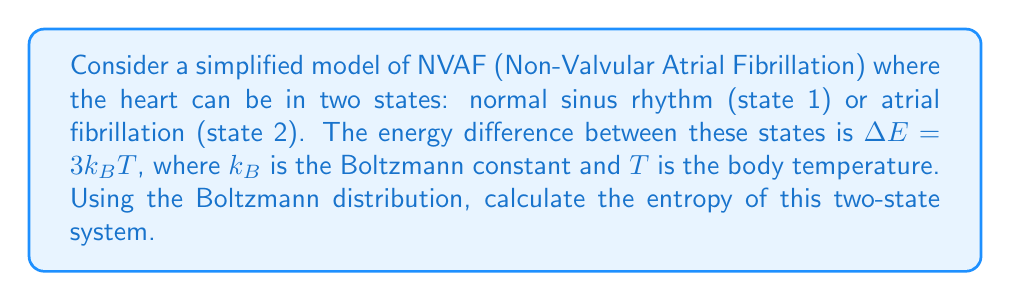Help me with this question. To solve this problem, we'll follow these steps:

1) The Boltzmann distribution gives the probability of a system being in a state with energy $E_i$:

   $$p_i = \frac{1}{Z} e^{-E_i/k_BT}$$

   where $Z$ is the partition function.

2) For a two-state system, the partition function is:

   $$Z = e^{-E_1/k_BT} + e^{-E_2/k_BT}$$

3) Let's set $E_1 = 0$ (reference state) and $E_2 = \Delta E = 3k_BT$. Then:

   $$Z = 1 + e^{-3} = 1 + 0.0498 = 1.0498$$

4) The probabilities of being in each state are:

   $$p_1 = \frac{1}{Z} = \frac{1}{1.0498} = 0.9525$$
   $$p_2 = \frac{e^{-3}}{Z} = \frac{0.0498}{1.0498} = 0.0475$$

5) The entropy of a discrete system is given by:

   $$S = -k_B \sum_i p_i \ln p_i$$

6) Substituting the probabilities:

   $$S = -k_B (0.9525 \ln 0.9525 + 0.0475 \ln 0.0475)$$

7) Calculating:

   $$S = -k_B (-0.0487 - 0.1447) = 0.1934k_B$$

Therefore, the entropy of this two-state NVAF model is $0.1934k_B$.
Answer: $0.1934k_B$ 